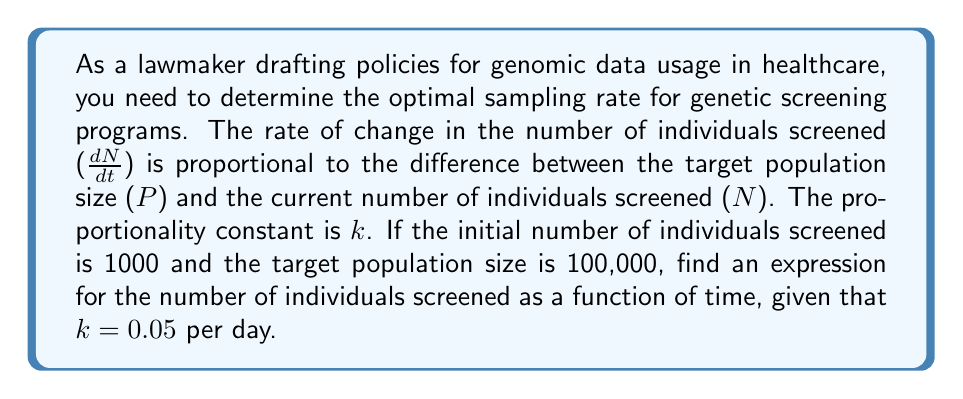What is the answer to this math problem? To solve this problem, we need to follow these steps:

1) First, let's identify the differential equation based on the given information:

   $$\frac{dN}{dt} = k(P - N)$$

   where $N$ is the number of individuals screened, $t$ is time in days, $k$ is the proportionality constant, and $P$ is the target population size.

2) We're given that $k = 0.05$ per day, $P = 100,000$, and the initial condition $N(0) = 1000$.

3) This is a first-order linear differential equation. We can solve it using the following steps:

   a) Rearrange the equation:
      $$\frac{dN}{dt} + 0.05N = 0.05 \cdot 100,000 = 5000$$

   b) The integrating factor is $e^{\int 0.05 dt} = e^{0.05t}$

   c) Multiply both sides by the integrating factor:
      $$e^{0.05t}\frac{dN}{dt} + 0.05e^{0.05t}N = 5000e^{0.05t}$$

   d) The left side is now the derivative of $e^{0.05t}N$, so we can write:
      $$\frac{d}{dt}(e^{0.05t}N) = 5000e^{0.05t}$$

   e) Integrate both sides:
      $$e^{0.05t}N = 100,000e^{0.05t} + C$$

   f) Solve for $N$:
      $$N = 100,000 + Ce^{-0.05t}$$

4) Use the initial condition $N(0) = 1000$ to find $C$:
   $$1000 = 100,000 + C$$
   $$C = -99,000$$

5) Therefore, the final solution is:
   $$N = 100,000 - 99,000e^{-0.05t}$$

This expression gives the number of individuals screened as a function of time in days.
Answer: $N = 100,000 - 99,000e^{-0.05t}$, where $N$ is the number of individuals screened and $t$ is time in days. 